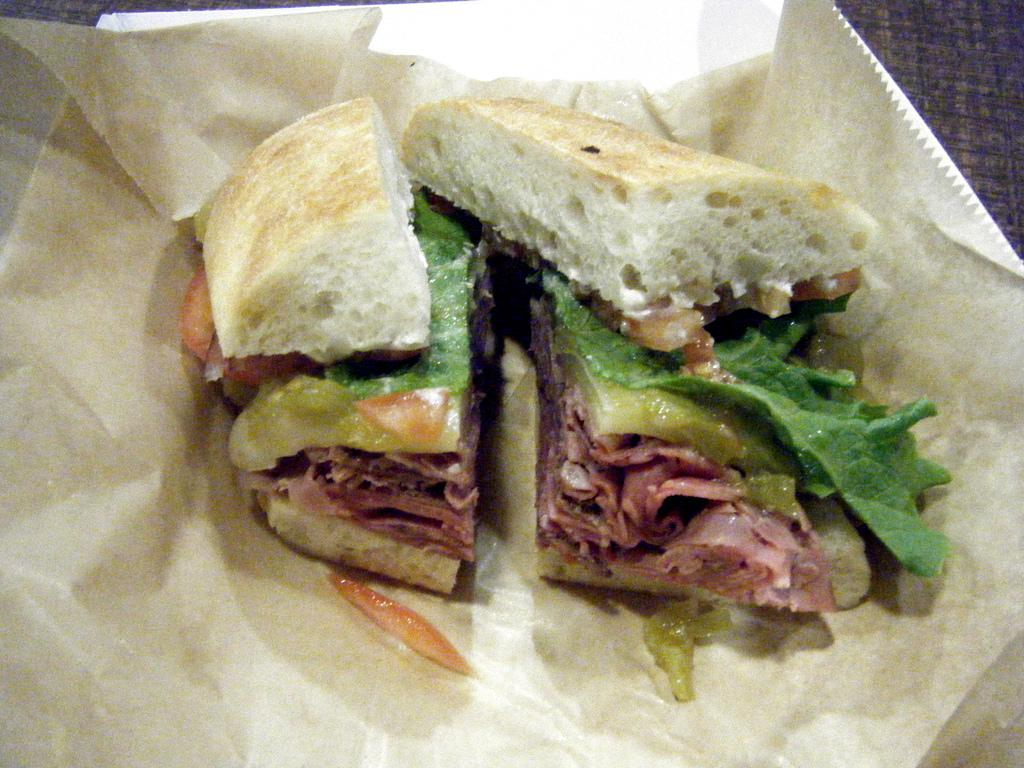What is present on the paper in the image? There are food items on a paper in the image. Where is the paper with food items located? The paper is on a plate. What type of power source can be seen in the image? There is no power source present in the image. Is there a cave visible in the image? There is no cave present in the image. What type of fruit is visible on the plate in the image? The image does not show any fruit; it only shows food items on a paper. 